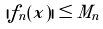Convert formula to latex. <formula><loc_0><loc_0><loc_500><loc_500>| f _ { n } ( x ) | \leq M _ { n }</formula> 